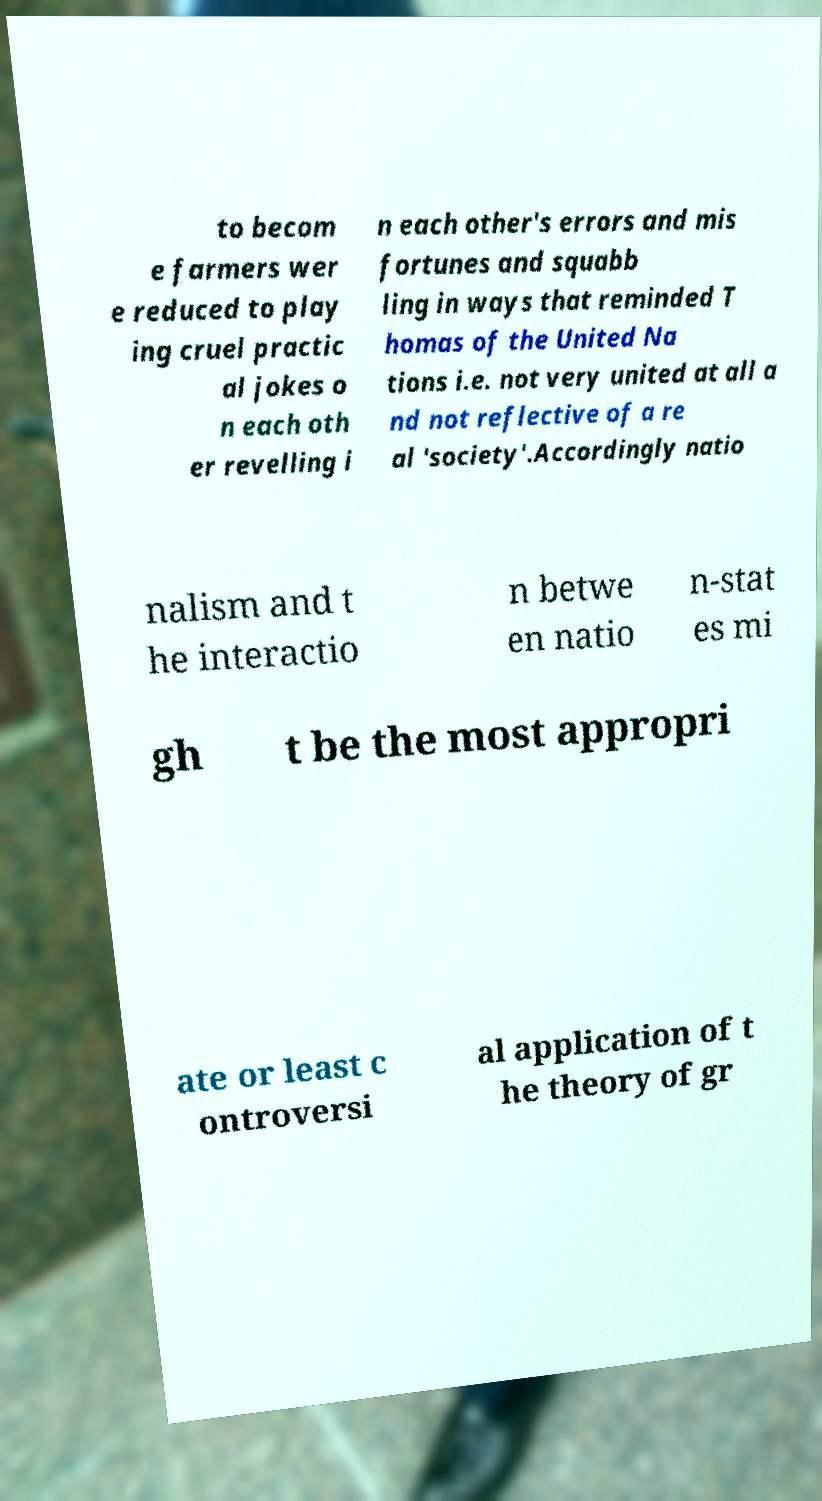What messages or text are displayed in this image? I need them in a readable, typed format. to becom e farmers wer e reduced to play ing cruel practic al jokes o n each oth er revelling i n each other's errors and mis fortunes and squabb ling in ways that reminded T homas of the United Na tions i.e. not very united at all a nd not reflective of a re al 'society'.Accordingly natio nalism and t he interactio n betwe en natio n-stat es mi gh t be the most appropri ate or least c ontroversi al application of t he theory of gr 